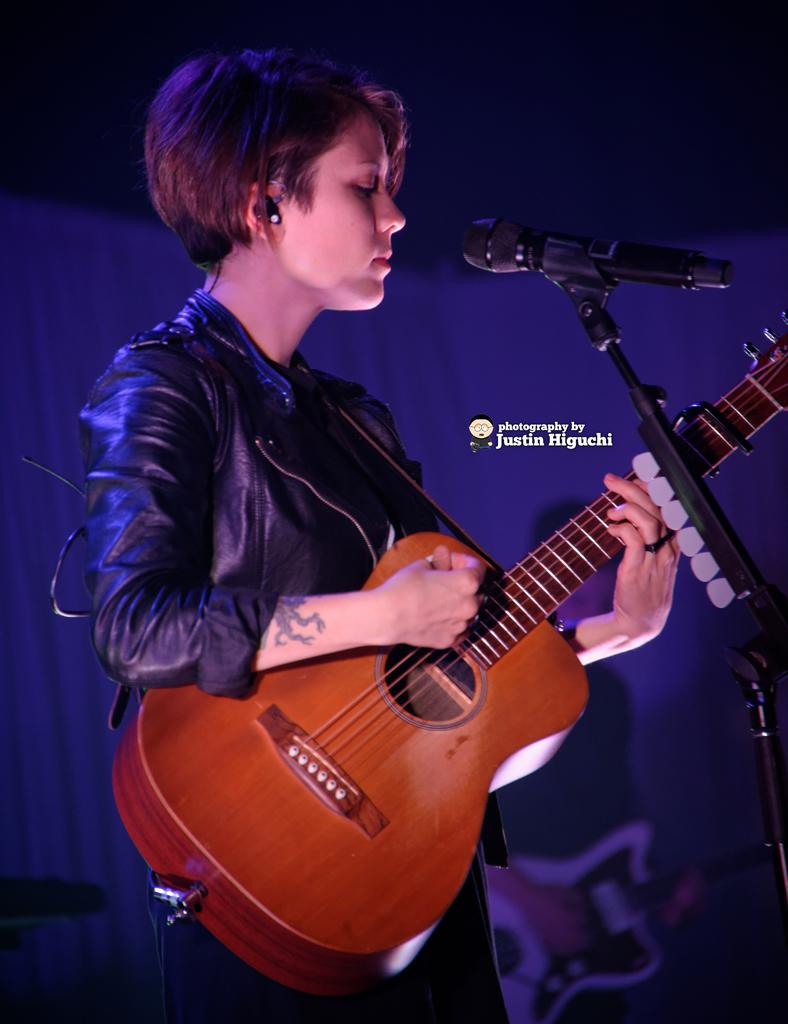What is the person in the image doing? The person is playing the guitar. What is the person wearing in the image? The person is wearing a black jacket. What is the person's posture in the image? The person is standing. What object is in front of the person in the image? There is a microphone stand in front of the person. What type of ring can be seen on the person's finger in the image? There is no ring visible on the person's finger in the image. How many quarters are visible on the floor in the image? There are no quarters visible on the floor in the image. 